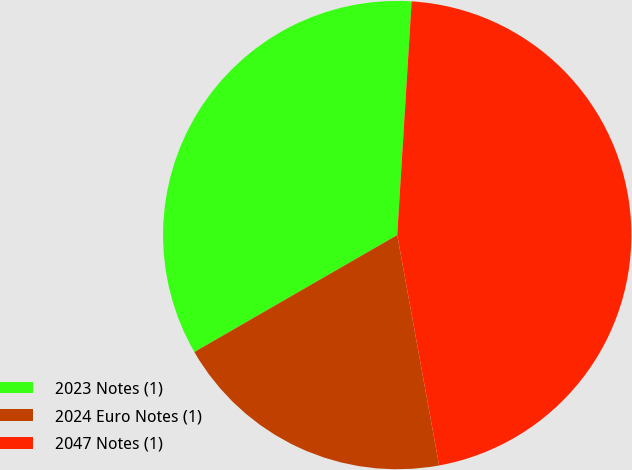Convert chart to OTSL. <chart><loc_0><loc_0><loc_500><loc_500><pie_chart><fcel>2023 Notes (1)<fcel>2024 Euro Notes (1)<fcel>2047 Notes (1)<nl><fcel>34.3%<fcel>19.54%<fcel>46.15%<nl></chart> 